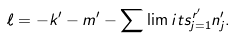Convert formula to latex. <formula><loc_0><loc_0><loc_500><loc_500>\ell = - k ^ { \prime } - m ^ { \prime } - \sum \lim i t s _ { j = 1 } ^ { r ^ { \prime } } n _ { j } ^ { \prime } .</formula> 